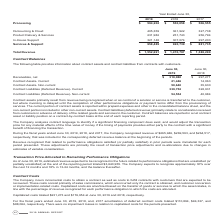According to Jack Henry Associates's financial document, What information does the table show? information about contract assets and contract liabilities from contracts with customers. The document states: "The following table provides information about contract assets and contract liabilities from contracts with customers...." Also, What is the net receivables as at June 30, 2019? According to the financial document, $310,080. The relevant text states: "Receivables, net $ 310,080 $ 297,271..." Also, What is the current contract assets as at June 30, 2019? According to the financial document, 21,446. The relevant text states: "Contract Assets- Current 21,446 14,063..." Additionally, Between June 30, 2019 and June 30, 2018, which year end had higher net receivables? According to the financial document, 2019. The relevant text states: "2019 2018 2017..." Additionally, Is current or non-current contract assets as at June 30, 2019 higher? Contract Assets- Non-current. The document states: "Contract Assets- Non-current 50,640 35,630..." Also, can you calculate: What is the average net receivables for 2018 and 2019? To answer this question, I need to perform calculations using the financial data. The calculation is: (310,080+297,271)/2, which equals 303675.5. This is based on the information: "Receivables, net $ 310,080 $ 297,271 Receivables, net $ 310,080 $ 297,271..." The key data points involved are: 297,271, 310,080. 